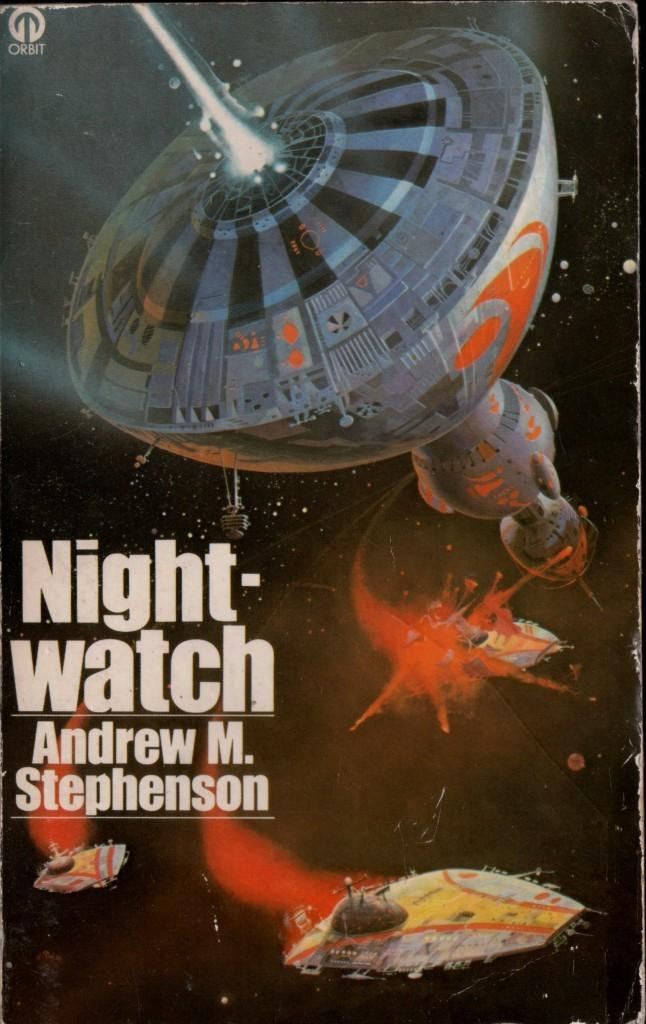<image>
Relay a brief, clear account of the picture shown. Space ships in battle showing a scene from a book by Andrew Stephenson. 